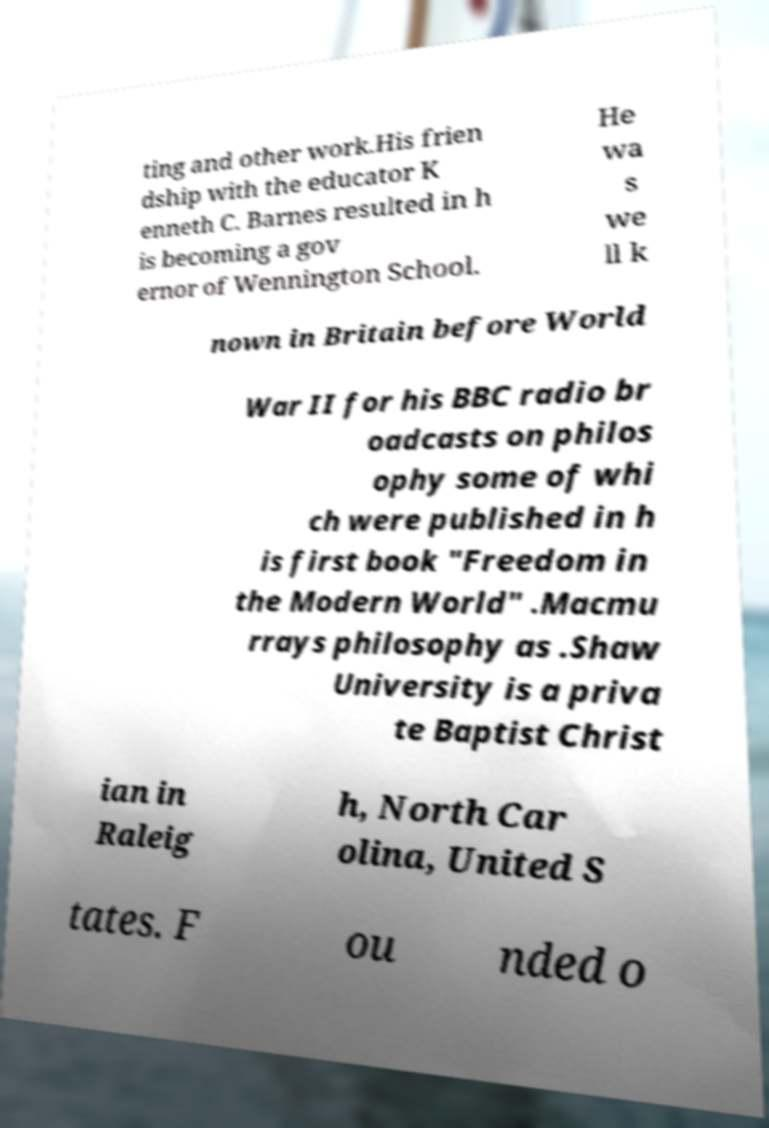Please read and relay the text visible in this image. What does it say? ting and other work.His frien dship with the educator K enneth C. Barnes resulted in h is becoming a gov ernor of Wennington School. He wa s we ll k nown in Britain before World War II for his BBC radio br oadcasts on philos ophy some of whi ch were published in h is first book "Freedom in the Modern World" .Macmu rrays philosophy as .Shaw University is a priva te Baptist Christ ian in Raleig h, North Car olina, United S tates. F ou nded o 